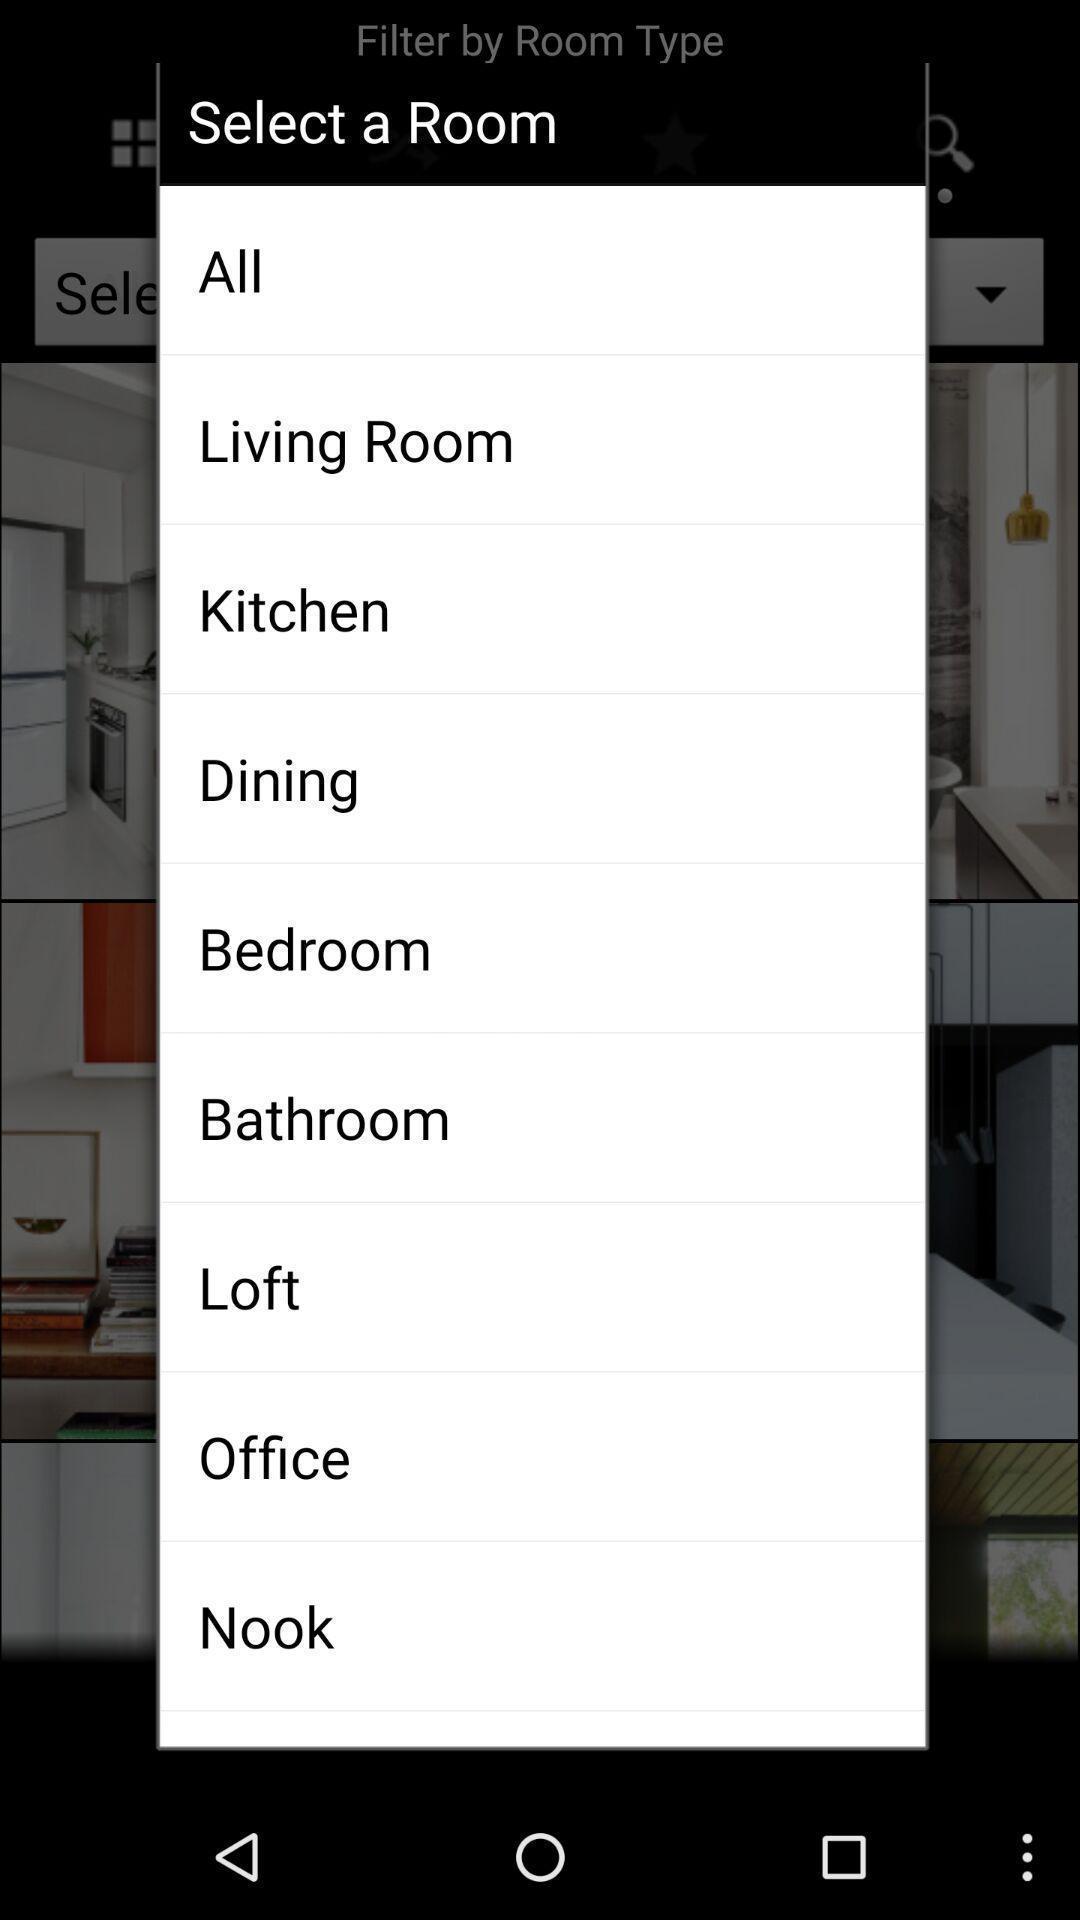Explain the elements present in this screenshot. Screen displaying the list of rooms to select. 